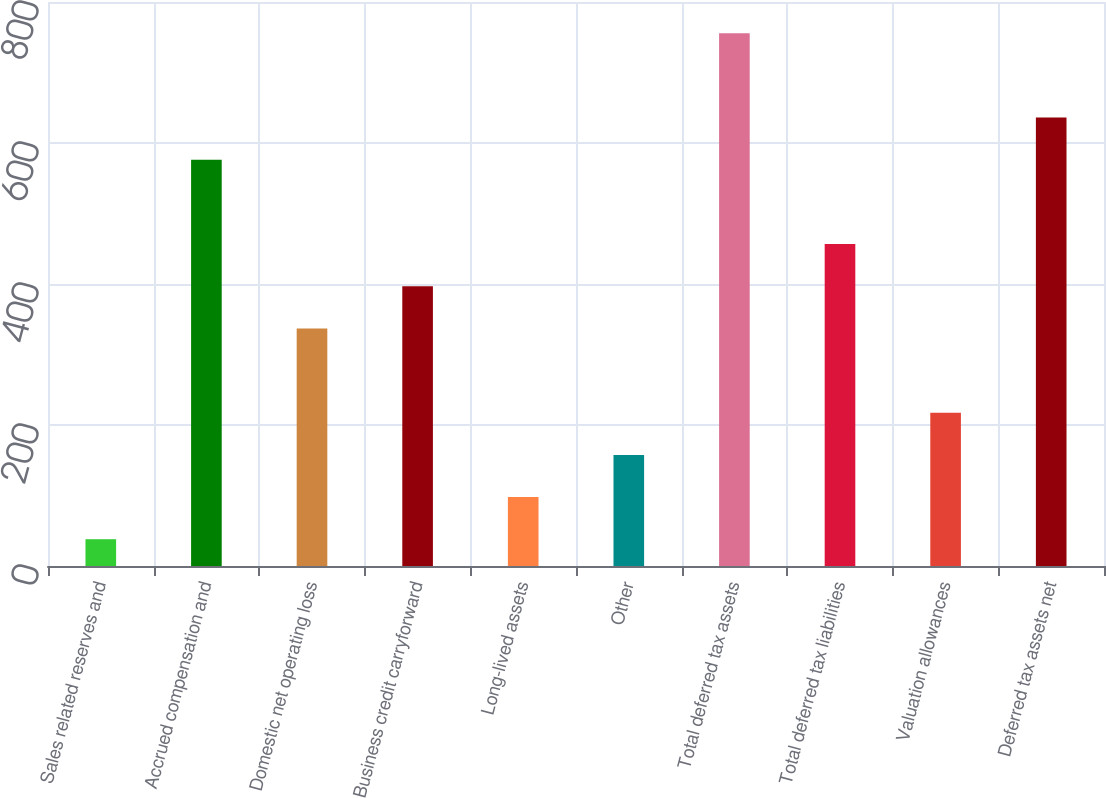Convert chart to OTSL. <chart><loc_0><loc_0><loc_500><loc_500><bar_chart><fcel>Sales related reserves and<fcel>Accrued compensation and<fcel>Domestic net operating loss<fcel>Business credit carryforward<fcel>Long-lived assets<fcel>Other<fcel>Total deferred tax assets<fcel>Total deferred tax liabilities<fcel>Valuation allowances<fcel>Deferred tax assets net<nl><fcel>38<fcel>576.2<fcel>337<fcel>396.8<fcel>97.8<fcel>157.6<fcel>755.6<fcel>456.6<fcel>217.4<fcel>636<nl></chart> 